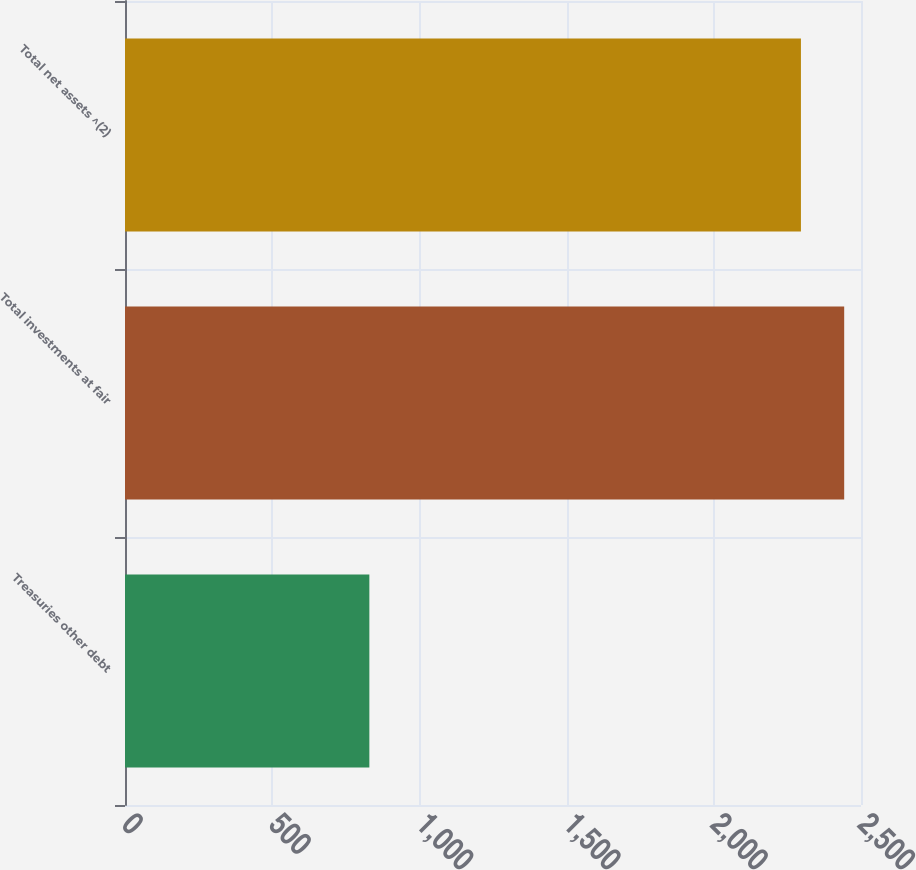<chart> <loc_0><loc_0><loc_500><loc_500><bar_chart><fcel>Treasuries other debt<fcel>Total investments at fair<fcel>Total net assets ^(2)<nl><fcel>830<fcel>2442.9<fcel>2296<nl></chart> 